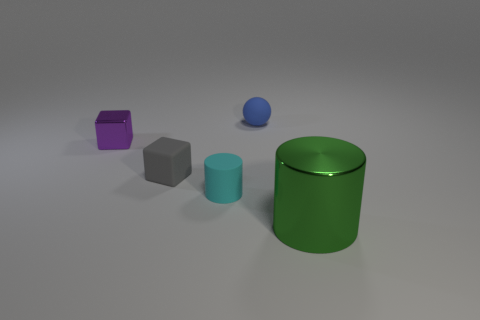Add 3 gray rubber objects. How many objects exist? 8 Subtract all blocks. How many objects are left? 3 Add 3 green metal things. How many green metal things are left? 4 Add 1 shiny cylinders. How many shiny cylinders exist? 2 Subtract 0 green cubes. How many objects are left? 5 Subtract all small yellow blocks. Subtract all small rubber balls. How many objects are left? 4 